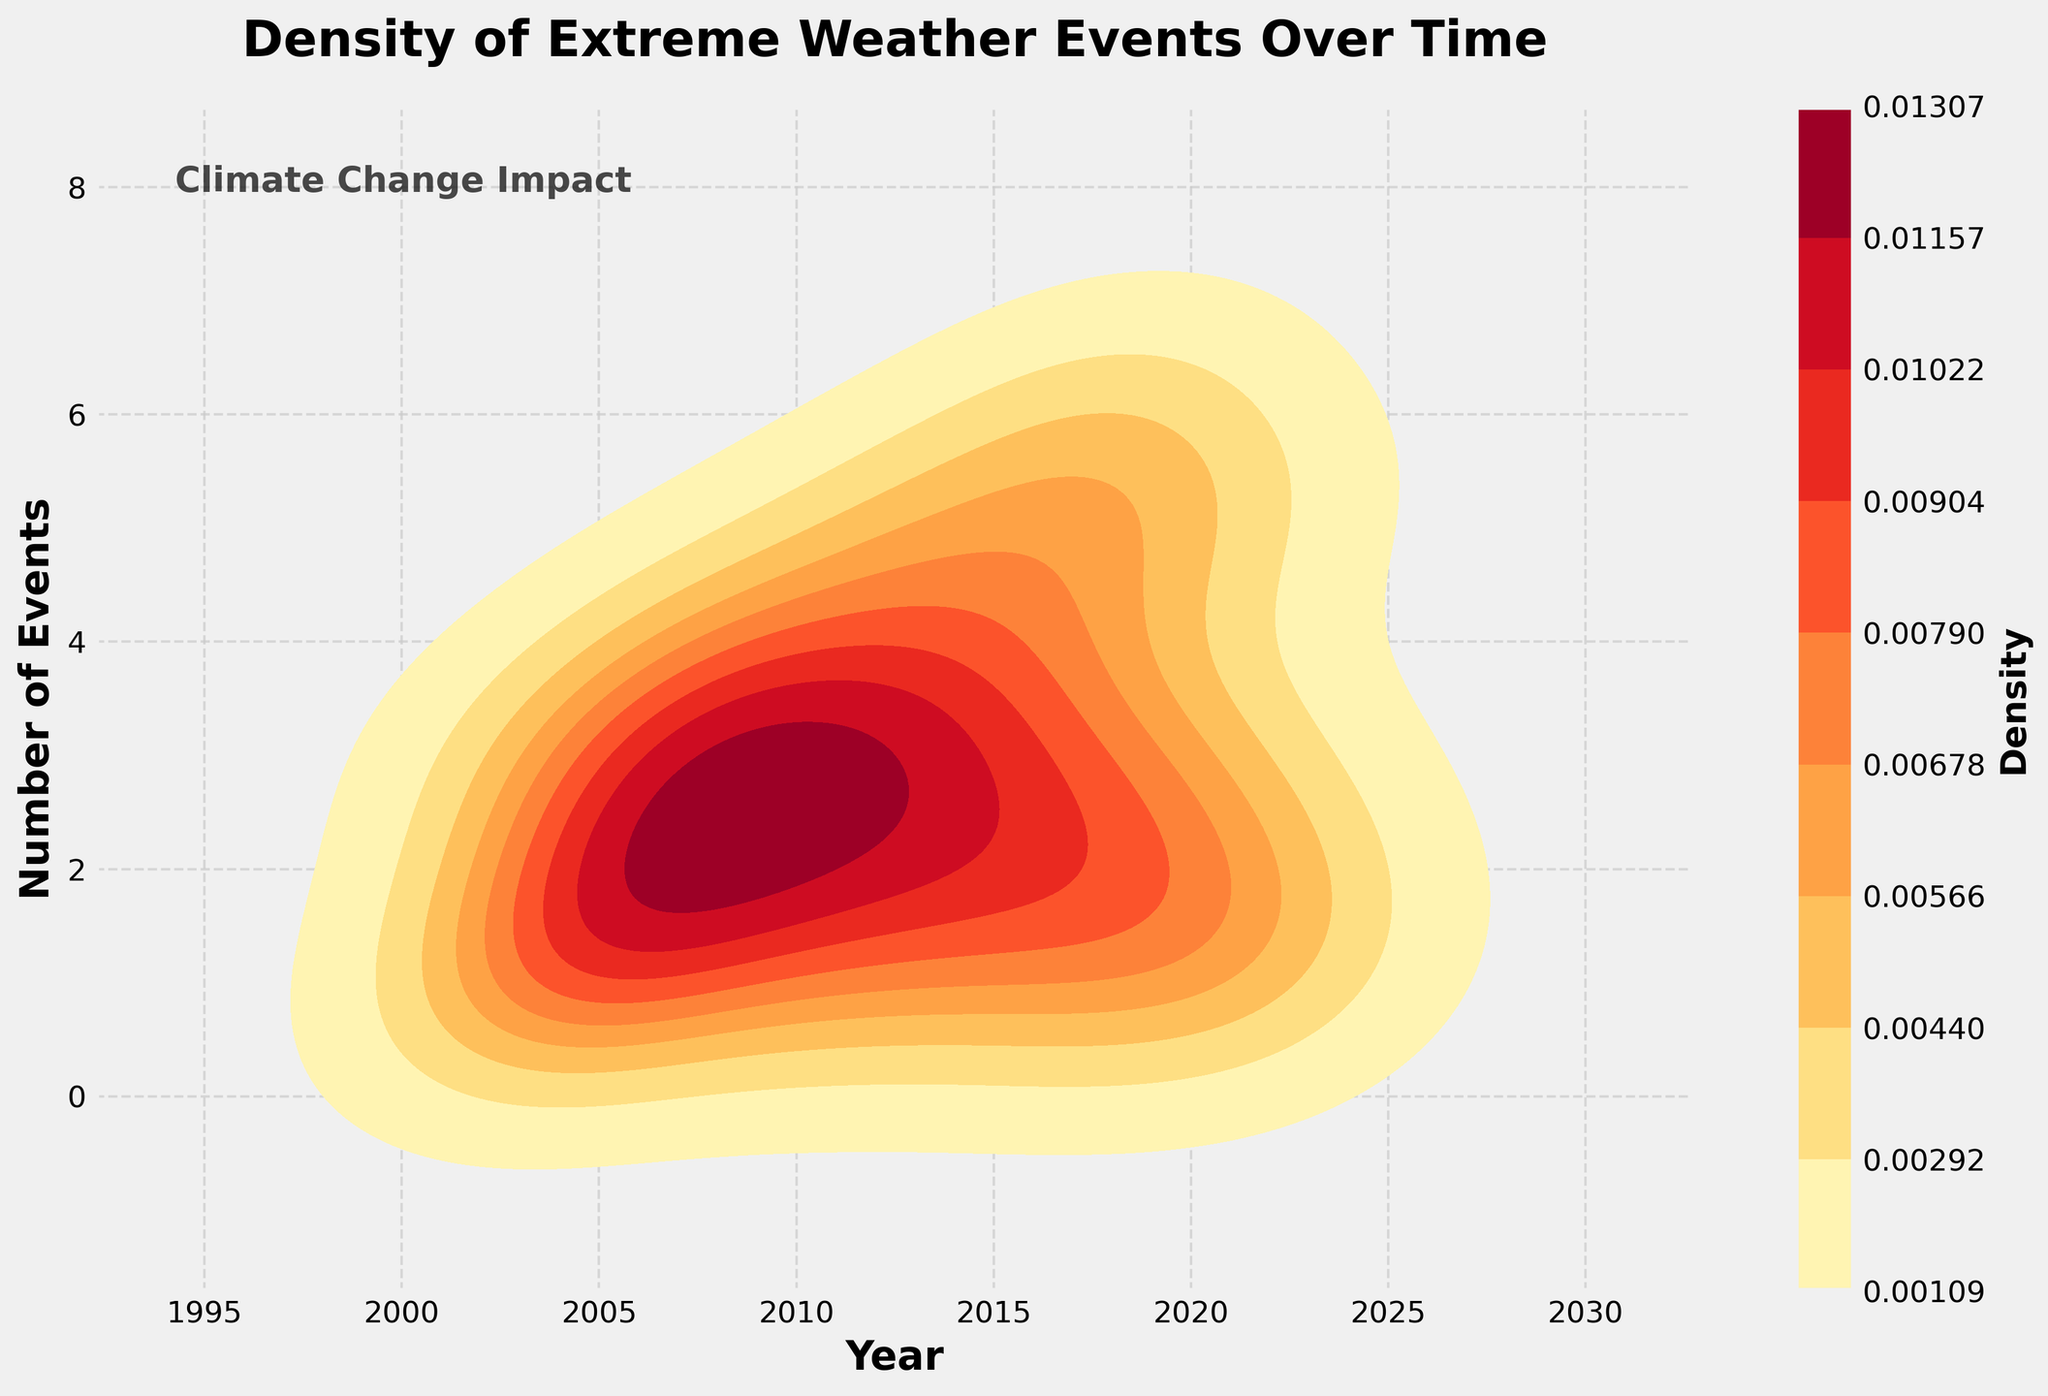What's the title of the figure? The title of the figure is typically found at the top and gives an overview of what the plot represents. In this case, it is clearly stated.
Answer: Density of Extreme Weather Events Over Time What are the labels on the axes of the figure? The labels on the axes help us understand what each axis represents. Here, the X-axis is labeled 'Year' which provides a timeline, and the Y-axis is labeled 'Number of Events' which indicates how many extreme weather events occurred.
Answer: 'Year' and 'Number of Events' Which years appear to have the highest density of extreme weather events? The regions with darker colors in a density plot indicate higher density. By observing the figure, we can identify which years have the darkest shades to determine the peak density periods.
Answer: 2015 and 2020 What is the general trend in the number of extreme weather events over the years? By analyzing the density plot, we can observe if there is an upward, downward, or fluctuating trend in the number of events over time by noting the concentration of shaded areas across the years.
Answer: Increasing trend Are there more moderate or severe extreme weather events over the past 20 years? This question requires us to integrate the information about event severity and their occurrences. From the data, we can infer that severe events dominate in terms of higher frequency and larger impact.
Answer: More severe events Between what years do you see a significant increase in the number of extreme weather events? Comparing the density levels visually over different time spans can reveal periods of noticeable increase in the number of events.
Answer: Between 2015 and 2020 Which year showed the lowest density of extreme weather events? The lowest density can be identified by finding the lightest or least shaded area on the density plot.
Answer: 2003 How does the density of extreme weather events in New Orleans compare to California over time? To answer this, we need to consider the frequency and intensity of events in each location by interpreting the density representation for each year. Specific values are not provided on a density plot, so relational interpretation is necessary.
Answer: New Orleans has fewer but more severe events, California has more frequent events What was the density of events like during 2011? Observing the specific point in time within the plot and interpreting the color density at 2011 helps us gauge the number of events in that year.
Answer: Moderate density Considering the density for years 2021 and 2022, is there an upward or downward trend in extreme weather events? By looking at the density color changes from 2021 to 2022, we can determine if the trend is increasing or decreasing based on whether the shade becomes darker or lighter.
Answer: Downward trend 